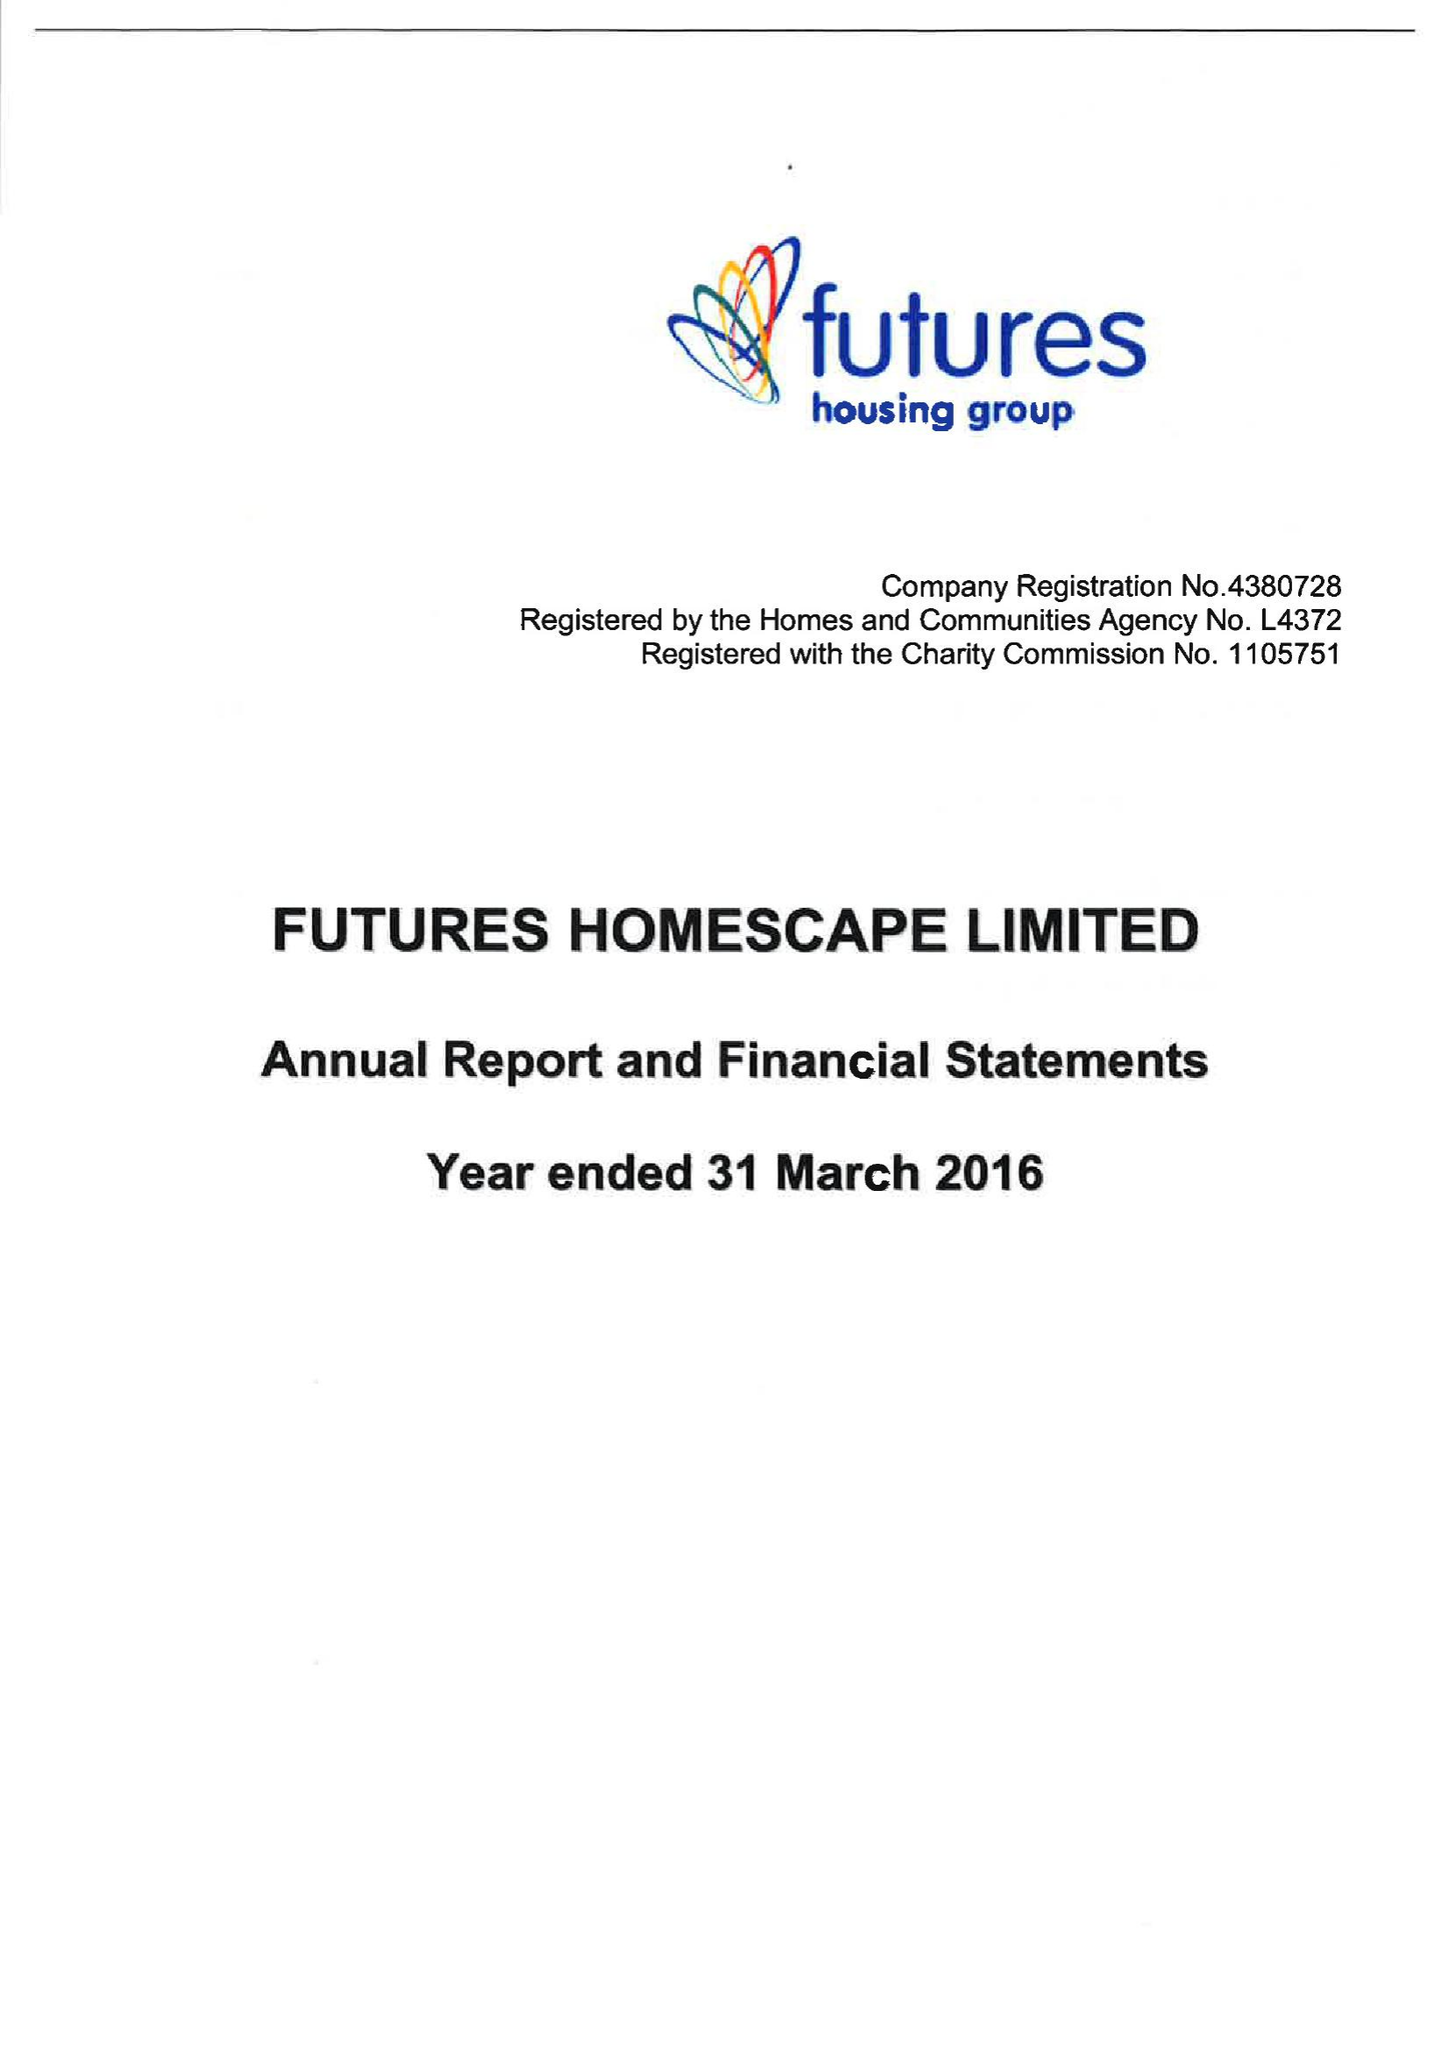What is the value for the income_annually_in_british_pounds?
Answer the question using a single word or phrase. 29866000.00 